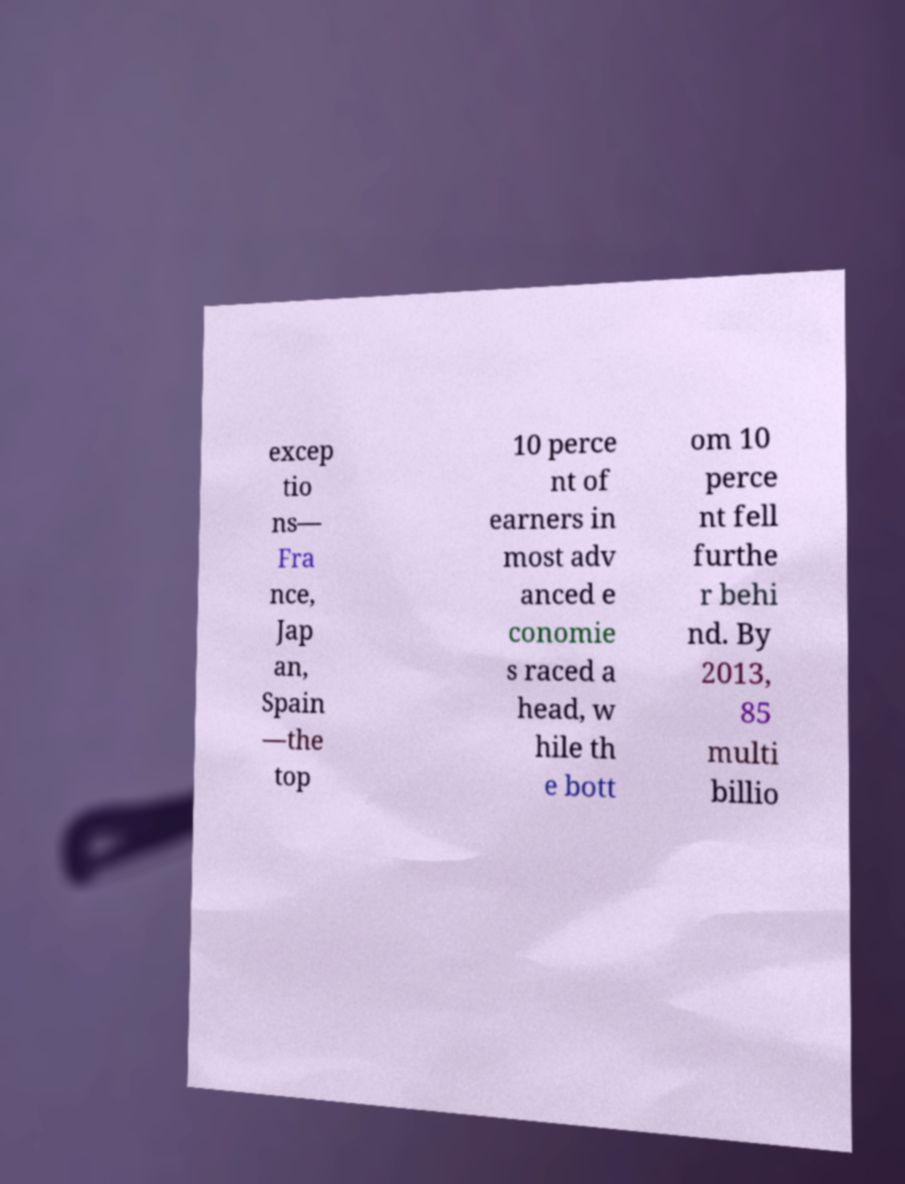There's text embedded in this image that I need extracted. Can you transcribe it verbatim? excep tio ns— Fra nce, Jap an, Spain —the top 10 perce nt of earners in most adv anced e conomie s raced a head, w hile th e bott om 10 perce nt fell furthe r behi nd. By 2013, 85 multi billio 